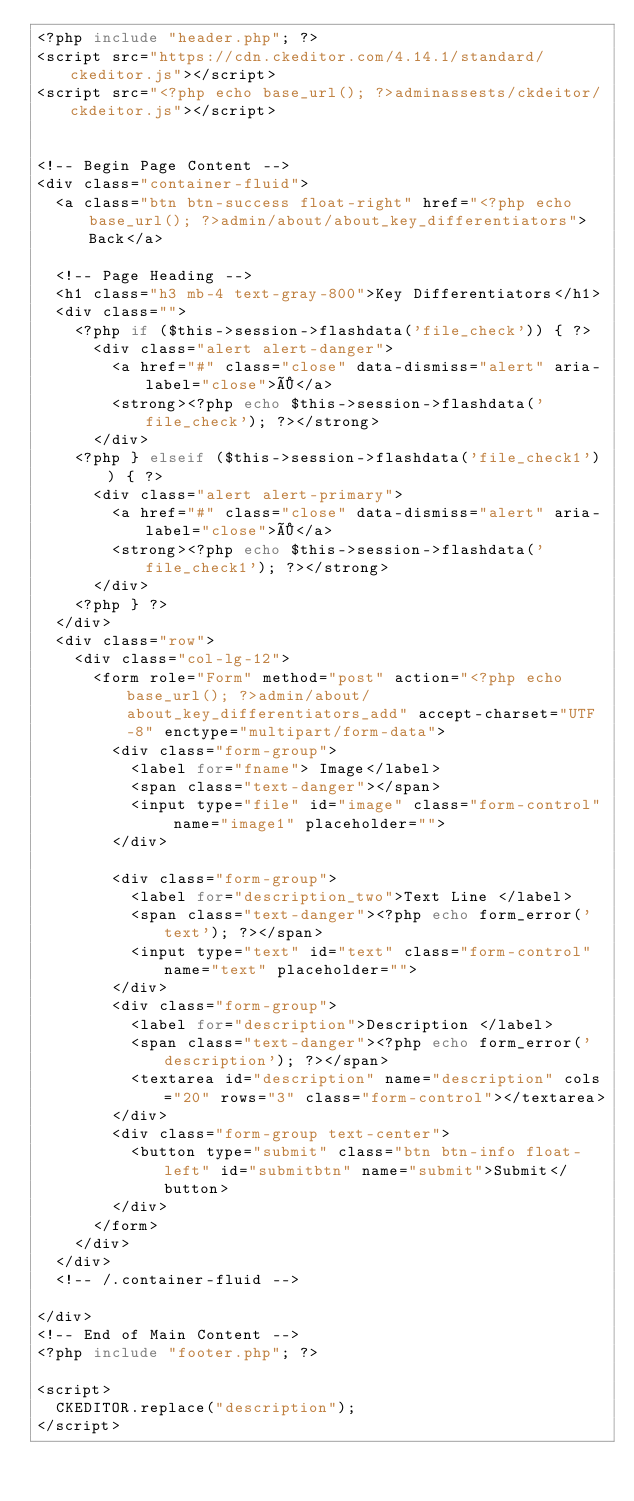Convert code to text. <code><loc_0><loc_0><loc_500><loc_500><_PHP_><?php include "header.php"; ?>
<script src="https://cdn.ckeditor.com/4.14.1/standard/ckeditor.js"></script>
<script src="<?php echo base_url(); ?>adminassests/ckdeitor/ckdeitor.js"></script>


<!-- Begin Page Content -->
<div class="container-fluid">
  <a class="btn btn-success float-right" href="<?php echo base_url(); ?>admin/about/about_key_differentiators">Back</a>

  <!-- Page Heading -->
  <h1 class="h3 mb-4 text-gray-800">Key Differentiators</h1>
  <div class="">
    <?php if ($this->session->flashdata('file_check')) { ?>
      <div class="alert alert-danger">
        <a href="#" class="close" data-dismiss="alert" aria-label="close">×</a>
        <strong><?php echo $this->session->flashdata('file_check'); ?></strong>
      </div>
    <?php } elseif ($this->session->flashdata('file_check1')) { ?>
      <div class="alert alert-primary">
        <a href="#" class="close" data-dismiss="alert" aria-label="close">×</a>
        <strong><?php echo $this->session->flashdata('file_check1'); ?></strong>
      </div>
    <?php } ?>
  </div>
  <div class="row">
    <div class="col-lg-12">
      <form role="Form" method="post" action="<?php echo base_url(); ?>admin/about/about_key_differentiators_add" accept-charset="UTF-8" enctype="multipart/form-data">
        <div class="form-group">
          <label for="fname"> Image</label>
          <span class="text-danger"></span>
          <input type="file" id="image" class="form-control" name="image1" placeholder="">
        </div>

        <div class="form-group">
          <label for="description_two">Text Line </label>
          <span class="text-danger"><?php echo form_error('text'); ?></span>
          <input type="text" id="text" class="form-control" name="text" placeholder="">
        </div>
        <div class="form-group">
          <label for="description">Description </label>
          <span class="text-danger"><?php echo form_error('description'); ?></span>
          <textarea id="description" name="description" cols="20" rows="3" class="form-control"></textarea>
        </div>
        <div class="form-group text-center">
          <button type="submit" class="btn btn-info float-left" id="submitbtn" name="submit">Submit</button>
        </div>
      </form>
    </div>
  </div>
  <!-- /.container-fluid -->

</div>
<!-- End of Main Content -->
<?php include "footer.php"; ?>

<script>
  CKEDITOR.replace("description");
</script></code> 